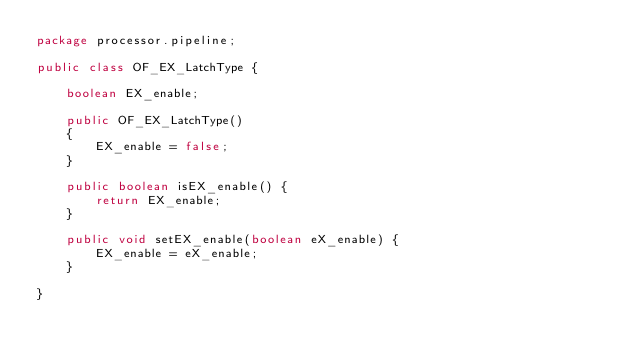Convert code to text. <code><loc_0><loc_0><loc_500><loc_500><_Java_>package processor.pipeline;

public class OF_EX_LatchType {
	
	boolean EX_enable;
	
	public OF_EX_LatchType()
	{
		EX_enable = false;
	}

	public boolean isEX_enable() {
		return EX_enable;
	}

	public void setEX_enable(boolean eX_enable) {
		EX_enable = eX_enable;
	}

}
</code> 